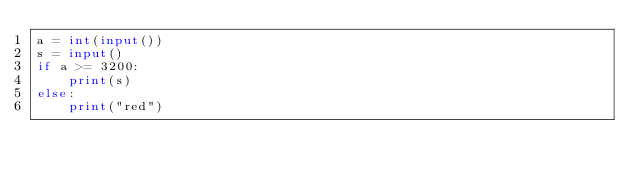Convert code to text. <code><loc_0><loc_0><loc_500><loc_500><_Python_>a = int(input())
s = input()
if a >= 3200:
    print(s)
else:
    print("red")</code> 